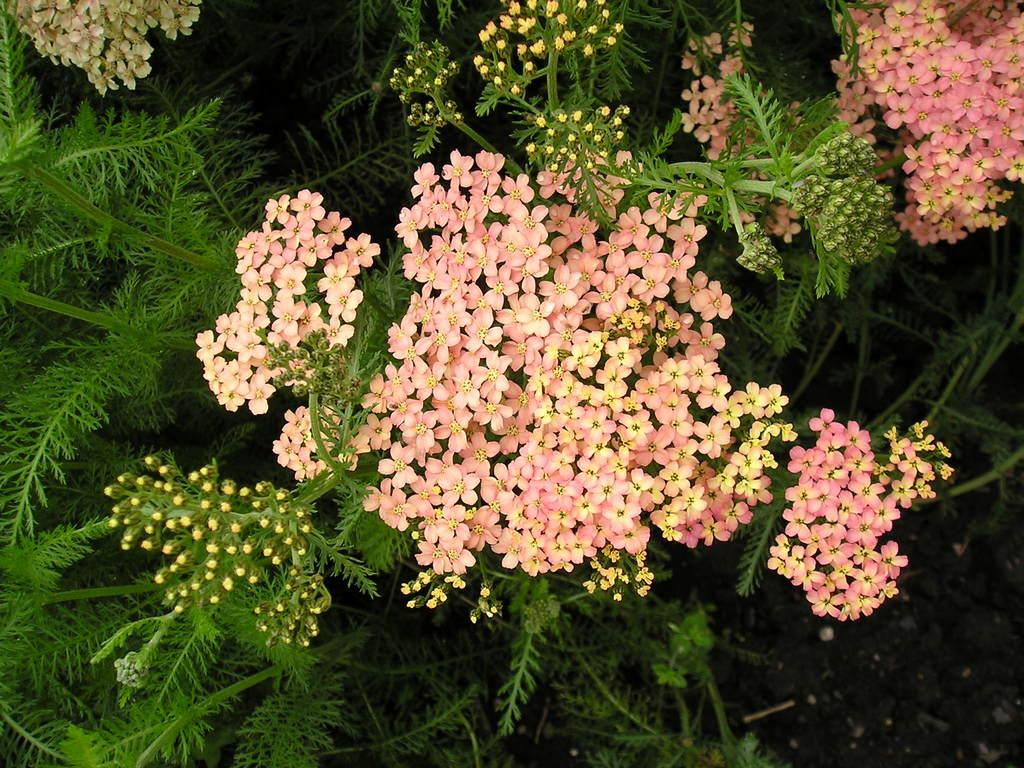What type of plant life is present in the image? There are flowers in the image. What parts of the flowers can be seen? The flowers have leaves and stems. Can you see a person interacting with the flowers in the image? There is no person present in the image; it only features flowers with leaves and stems. Is there a squirrel climbing on the flowers in the image? There is no squirrel present in the image; it only features flowers with leaves and stems. 